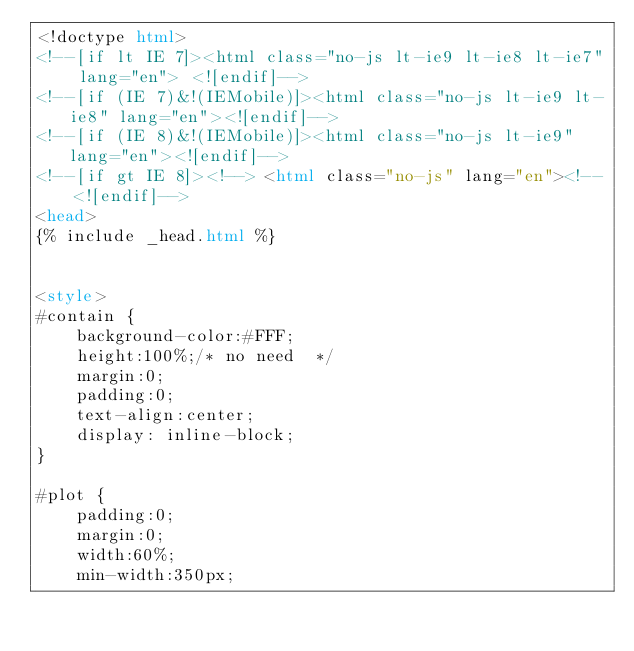Convert code to text. <code><loc_0><loc_0><loc_500><loc_500><_HTML_><!doctype html>
<!--[if lt IE 7]><html class="no-js lt-ie9 lt-ie8 lt-ie7" lang="en"> <![endif]-->
<!--[if (IE 7)&!(IEMobile)]><html class="no-js lt-ie9 lt-ie8" lang="en"><![endif]-->
<!--[if (IE 8)&!(IEMobile)]><html class="no-js lt-ie9" lang="en"><![endif]-->
<!--[if gt IE 8]><!--> <html class="no-js" lang="en"><!--<![endif]-->
<head>
{% include _head.html %}


<style>
#contain {
    background-color:#FFF;
    height:100%;/* no need  */
    margin:0;
    padding:0;
    text-align:center;
    display: inline-block;
}

#plot {
    padding:0;
    margin:0;
    width:60%;
    min-width:350px;   </code> 